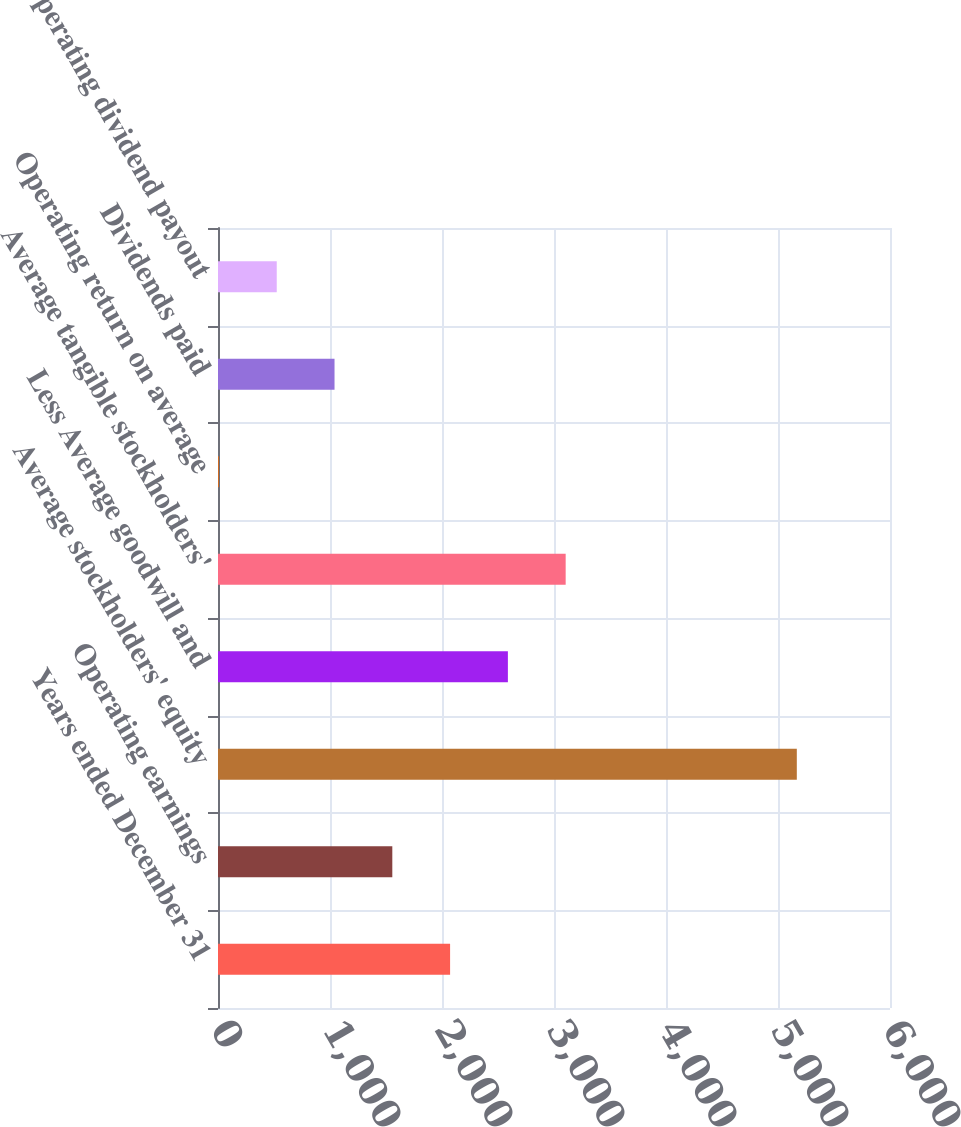<chart> <loc_0><loc_0><loc_500><loc_500><bar_chart><fcel>Years ended December 31<fcel>Operating earnings<fcel>Average stockholders' equity<fcel>Less Average goodwill and<fcel>Average tangible stockholders'<fcel>Operating return on average<fcel>Dividends paid<fcel>Operating dividend payout<nl><fcel>2072.3<fcel>1556.35<fcel>5168<fcel>2588.25<fcel>3104.2<fcel>8.5<fcel>1040.4<fcel>524.45<nl></chart> 